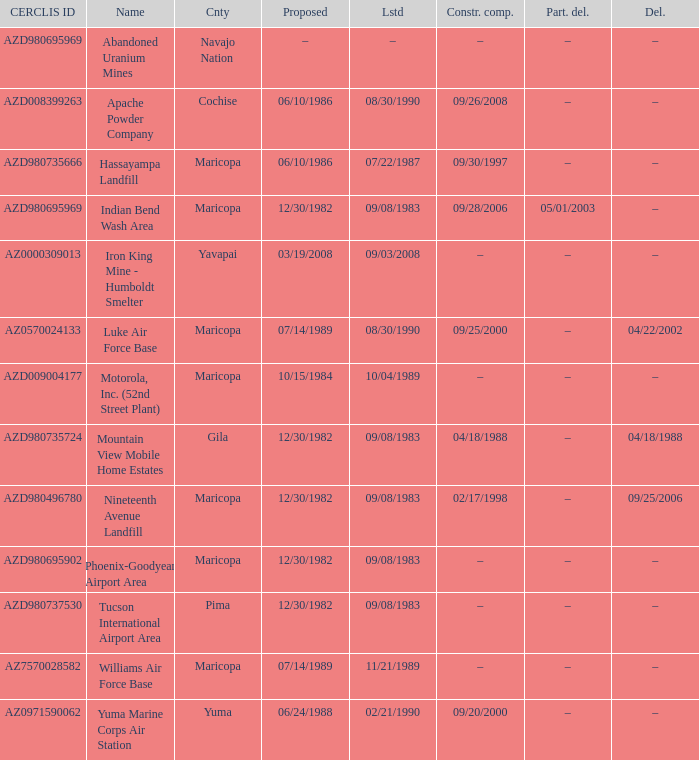What is the cerclis id when the site was proposed on 12/30/1982 and was partially deleted on 05/01/2003? AZD980695969. 